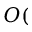<formula> <loc_0><loc_0><loc_500><loc_500>O (</formula> 